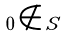<formula> <loc_0><loc_0><loc_500><loc_500>0 \notin S</formula> 